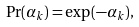Convert formula to latex. <formula><loc_0><loc_0><loc_500><loc_500>\Pr ( \alpha _ { k } ) = \exp ( - \alpha _ { k } ) ,</formula> 